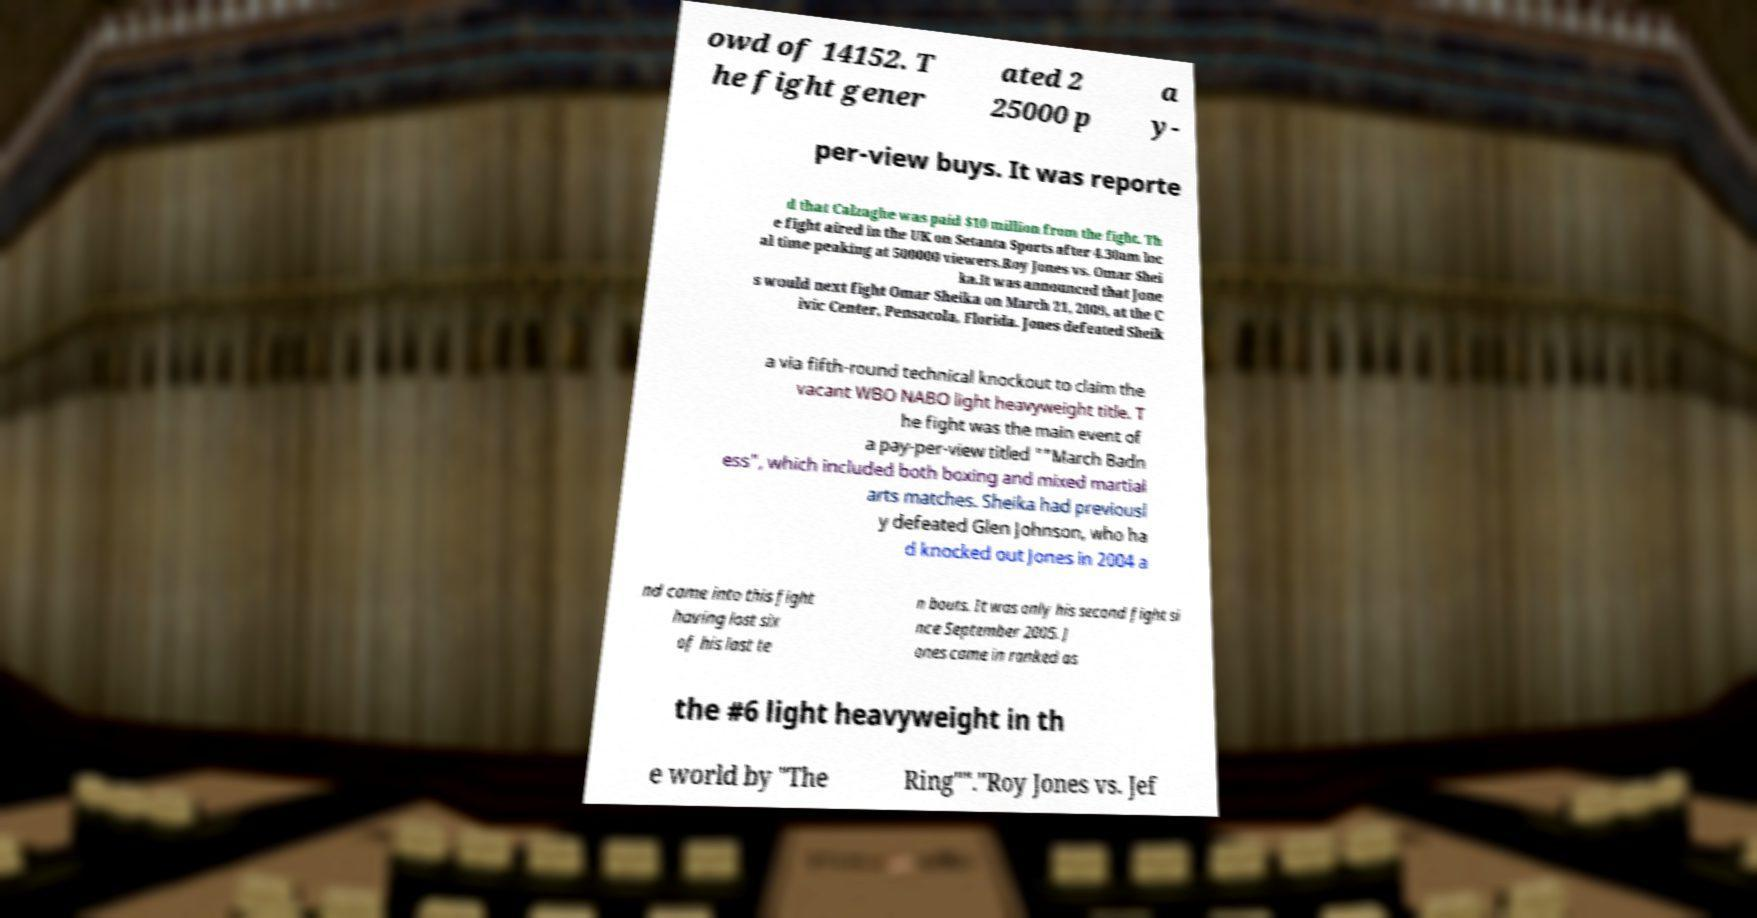Can you accurately transcribe the text from the provided image for me? owd of 14152. T he fight gener ated 2 25000 p a y- per-view buys. It was reporte d that Calzaghe was paid $10 million from the fight. Th e fight aired in the UK on Setanta Sports after 4.30am loc al time peaking at 500000 viewers.Roy Jones vs. Omar Shei ka.It was announced that Jone s would next fight Omar Sheika on March 21, 2009, at the C ivic Center, Pensacola, Florida. Jones defeated Sheik a via fifth-round technical knockout to claim the vacant WBO NABO light heavyweight title. T he fight was the main event of a pay-per-view titled ""March Badn ess", which included both boxing and mixed martial arts matches. Sheika had previousl y defeated Glen Johnson, who ha d knocked out Jones in 2004 a nd came into this fight having lost six of his last te n bouts. It was only his second fight si nce September 2005. J ones came in ranked as the #6 light heavyweight in th e world by "The Ring""."Roy Jones vs. Jef 